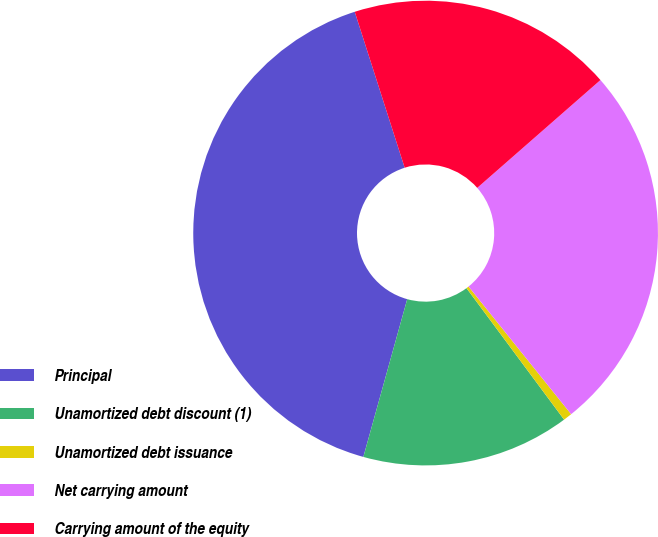<chart> <loc_0><loc_0><loc_500><loc_500><pie_chart><fcel>Principal<fcel>Unamortized debt discount (1)<fcel>Unamortized debt issuance<fcel>Net carrying amount<fcel>Carrying amount of the equity<nl><fcel>40.75%<fcel>14.48%<fcel>0.61%<fcel>25.67%<fcel>18.49%<nl></chart> 